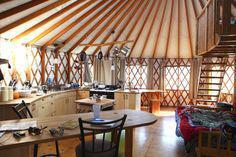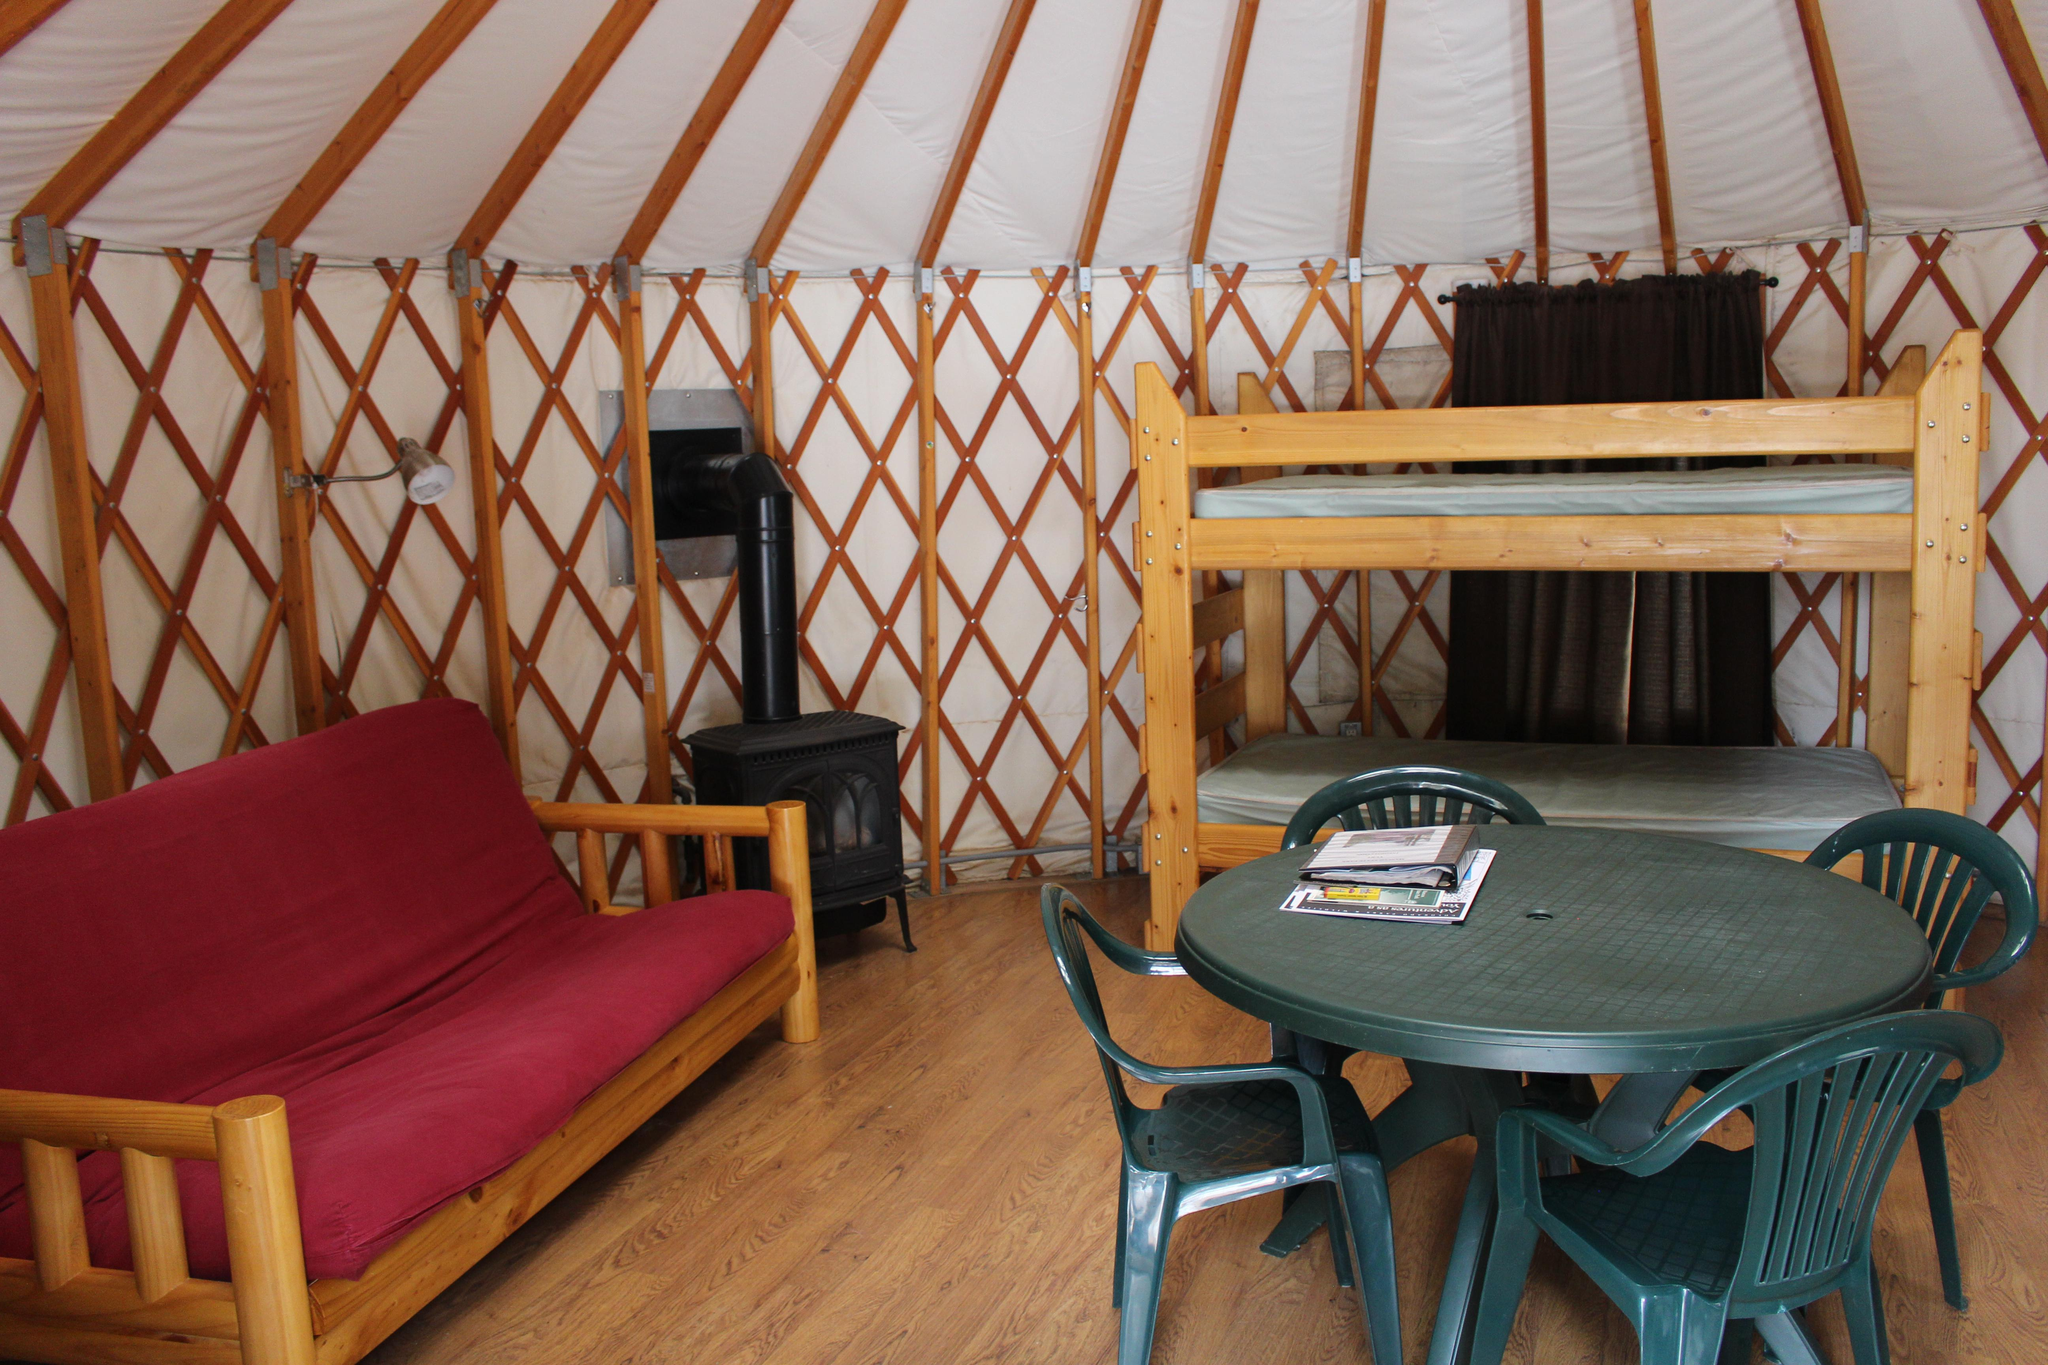The first image is the image on the left, the second image is the image on the right. For the images shown, is this caption "There is wooden floor in both images." true? Answer yes or no. Yes. The first image is the image on the left, the second image is the image on the right. For the images shown, is this caption "The image on the right contains at least one set of bunk beds." true? Answer yes or no. Yes. 